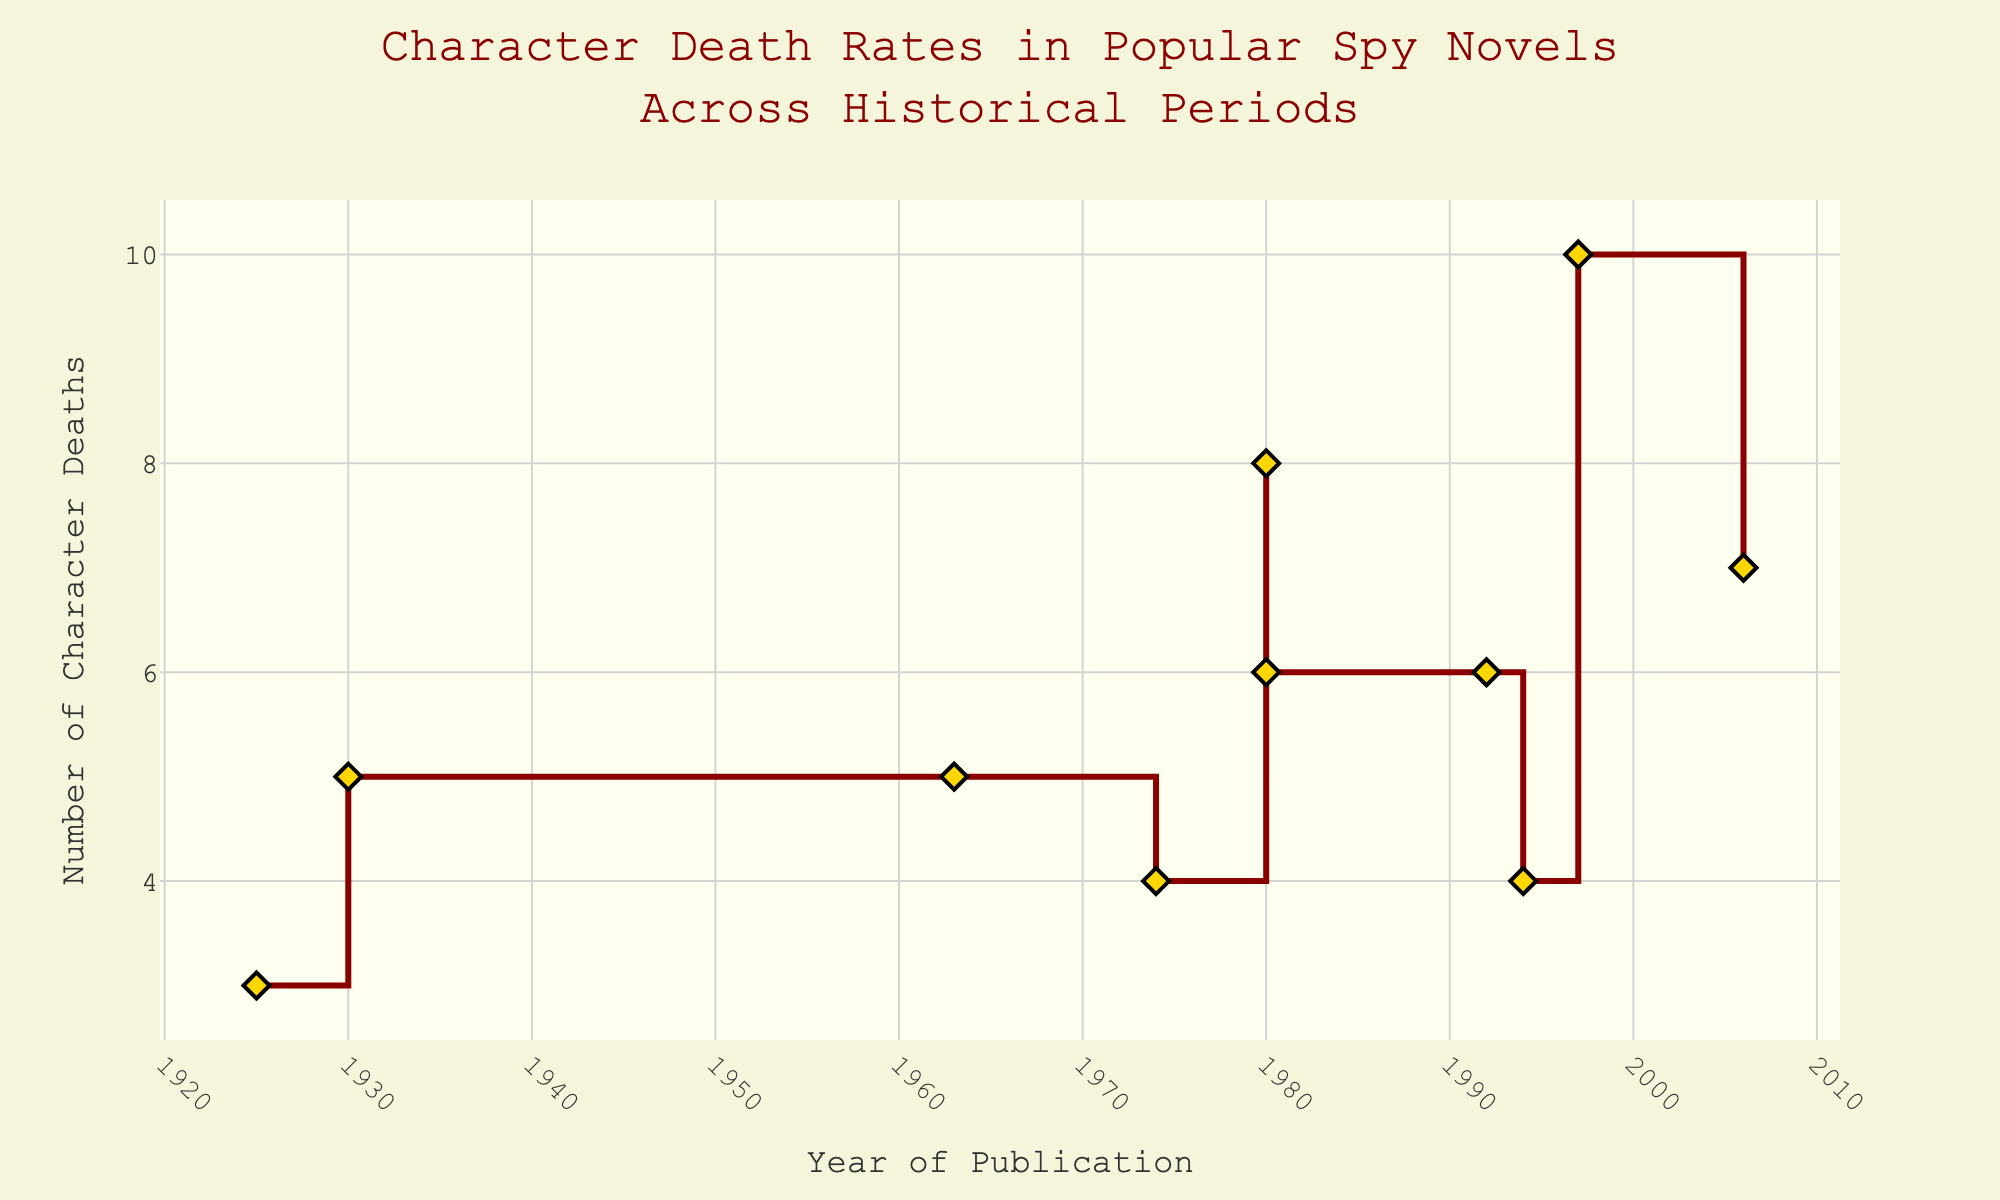What's the title of the stair plot? The title is typically found at the top of the plot. It provides context for the data being visualized. Here, it reads "Character Death Rates in Popular Spy Novels Across Historical Periods."
Answer: Character Death Rates in Popular Spy Novels Across Historical Periods What are the x-axis and y-axis labeled as? The axes give information about what is being measured or tracked. The x-axis shows "Year of Publication," and the y-axis shows "Number of Character Deaths."
Answer: Year of Publication, Number of Character Deaths Which novel has the highest number of character deaths and how many? To find this, look for the highest point on the y-axis. Hovering over points reveals the novel and its period. The highest point corresponds to "Sharpe's Tiger" with 10 deaths.
Answer: Sharpe's Tiger, 10 Which period has the most entries in the plot and how many novels does it have? Count the number of appearances for each period displayed when hovering over the data points. The "Cold War" period appears most frequently with 2 novels ("The Spy Who Came in from the Cold", "Tinker Tailor Soldier Spy").
Answer: Cold War, 2 Identify the first and last novels according to the publication year on the x-axis. By examining the x-axis range from the earliest to the latest years, the first novel is "The Great Gatsby" (1925) and the last is "The Night Watch" (2006).
Answer: The Great Gatsby, The Night Watch What are the character deaths for "The Bourne Identity," and which period is it set in? Hover over the point for "The Bourne Identity" in the plot to reveal the associated details. It shows 6 deaths and is set in the "Modern Day."
Answer: 6, Modern Day Plot-specific: How is the plot line shaped and colored? The plot uses a stepped/horizontal-vertical line (stair shape) colored in dark red, with markers shown as golden diamonds outlined in black.
Answer: Stepped shape, dark red What is the average number of character deaths across all novels in the plot? To calculate this, add up all character deaths and divide by the number of novels. The sum of deaths is 5+7+6+4+3+4+5+8+10+6=58. There are 10 novels, so the average is 58/10=5.8.
Answer: 5.8 Compare the character deaths in "The Alienist" and "The Name of the Rose." Which has more, and by how much? Hover over both novels to see the deaths count. "The Alienist" has 4 deaths and "The Name of the Rose" has 8 deaths. The difference is 8-4=4.
Answer: The Name of the Rose, 4 Identify the decade with the highest average character deaths based on the plot data. Group the novels by decade and calculate the average for each. For example, 1960s (5), 1970s (4), 1980s (6+8=14/2=7), 1990s (6+10=16/2=8), 2000s (7). The 1990s have the highest average at 8 deaths.
Answer: 1990s 